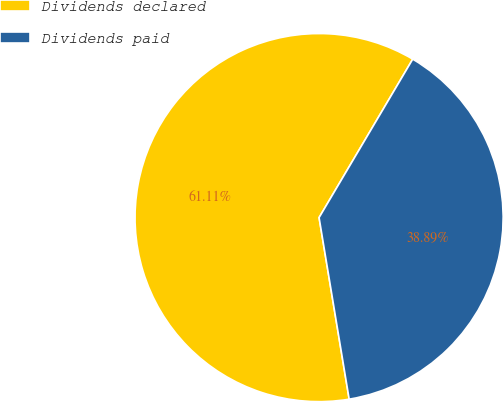<chart> <loc_0><loc_0><loc_500><loc_500><pie_chart><fcel>Dividends declared<fcel>Dividends paid<nl><fcel>61.11%<fcel>38.89%<nl></chart> 